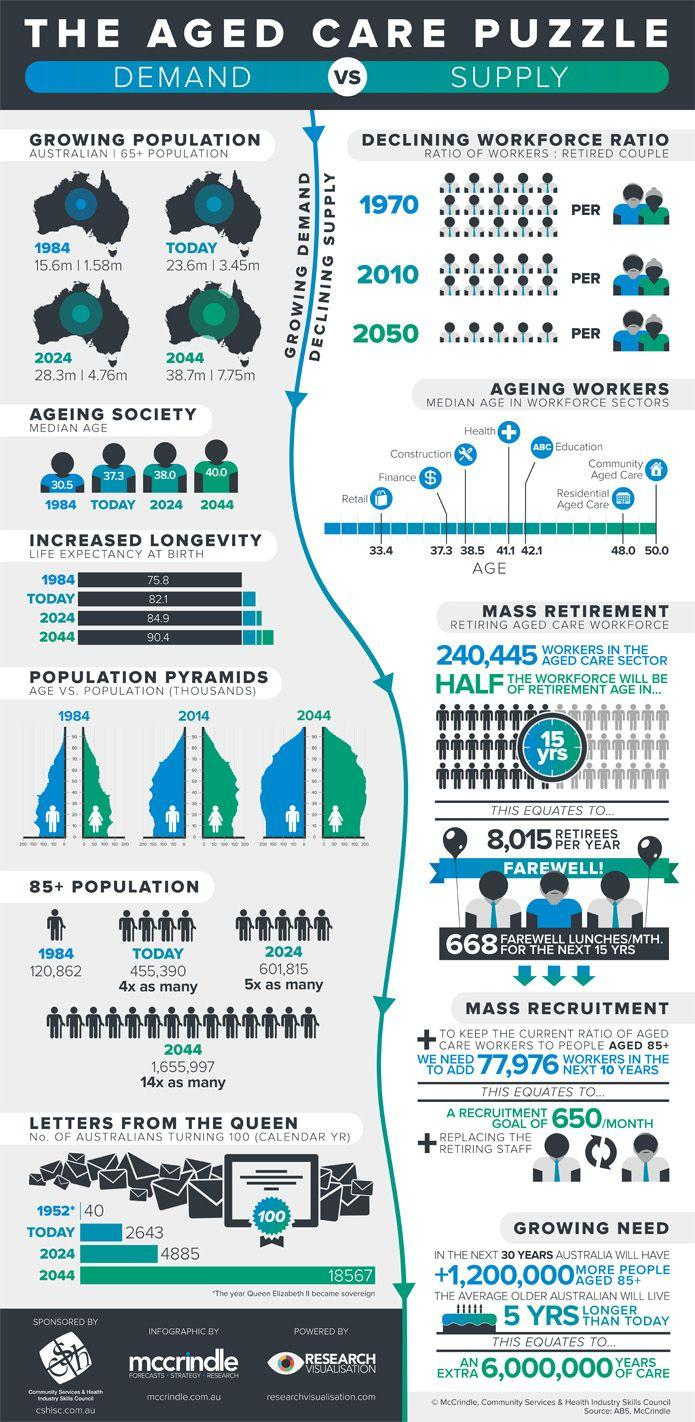Highlight a few significant elements in this photo. As of 2021, the current population of senior most (85+) Australian citizens is estimated to be 455,390. According to the data, the third-highest life expectancy rate is expected to be recorded in 2024. In the current year, an estimated 2,643 Australians will celebrate their 100th birthday. The current age of the average Australian is 37.3 years old. As of today, the senior citizen population in Australia is approximately 3.45 million. 